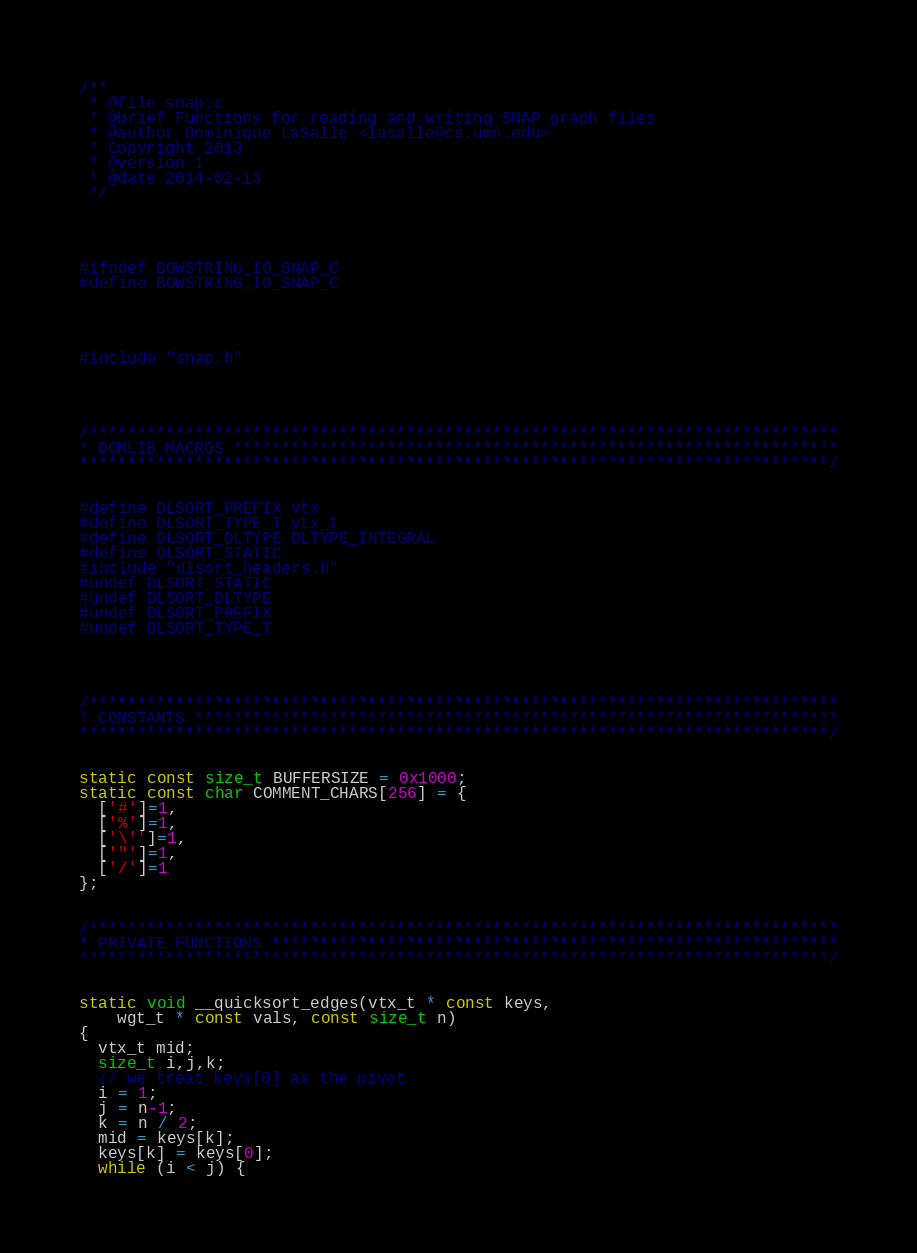Convert code to text. <code><loc_0><loc_0><loc_500><loc_500><_C_>/**
 * @file snap.c
 * @brief Functions for reading and writing SNAP graph files
 * @author Dominique LaSalle <lasalle@cs.umn.edu>
 * Copyright 2013
 * @version 1
 * @date 2014-02-13
 */




#ifndef BOWSTRING_IO_SNAP_C
#define BOWSTRING_IO_SNAP_C




#include "snap.h"




/******************************************************************************
* DOMLIB MACROS ***************************************************************
******************************************************************************/


#define DLSORT_PREFIX vtx
#define DLSORT_TYPE_T vtx_t
#define DLSORT_DLTYPE DLTYPE_INTEGRAL
#define DLSORT_STATIC
#include "dlsort_headers.h"
#undef DLSORT_STATIC
#undef DLSORT_DLTYPE
#undef DLSORT_PREFIX
#undef DLSORT_TYPE_T




/******************************************************************************
* CONSTANTS *******************************************************************
******************************************************************************/


static const size_t BUFFERSIZE = 0x1000;
static const char COMMENT_CHARS[256] = {
  ['#']=1,
  ['%']=1,
  ['\'']=1,
  ['"']=1,
  ['/']=1
};


/******************************************************************************
* PRIVATE FUNCTIONS ***********************************************************
******************************************************************************/


static void __quicksort_edges(vtx_t * const keys,
    wgt_t * const vals, const size_t n)
{
  vtx_t mid;
  size_t i,j,k;
  // we treat keys[0] as the pivot
  i = 1;
  j = n-1;
  k = n / 2;
  mid = keys[k];
  keys[k] = keys[0];
  while (i < j) {</code> 